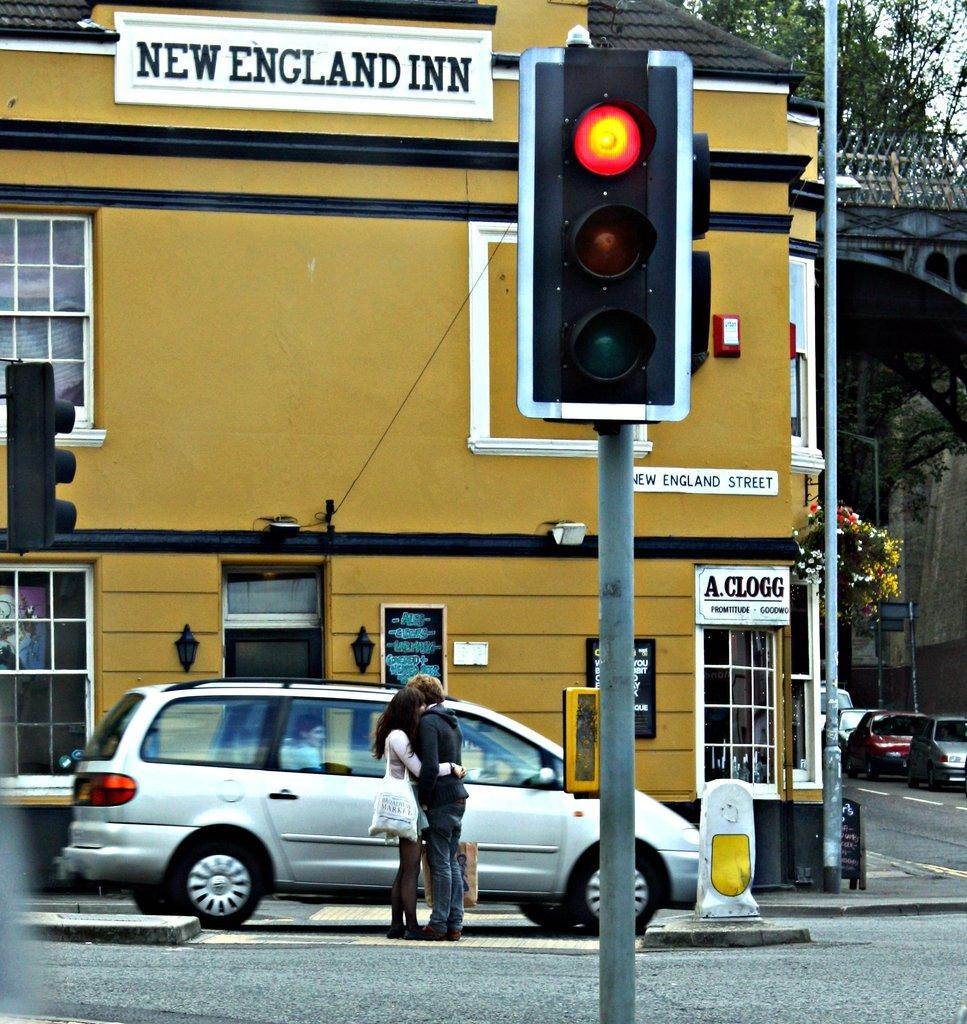Provide a one-sentence caption for the provided image. The New England INN is painted a mustard yellow color, with a black roof. 